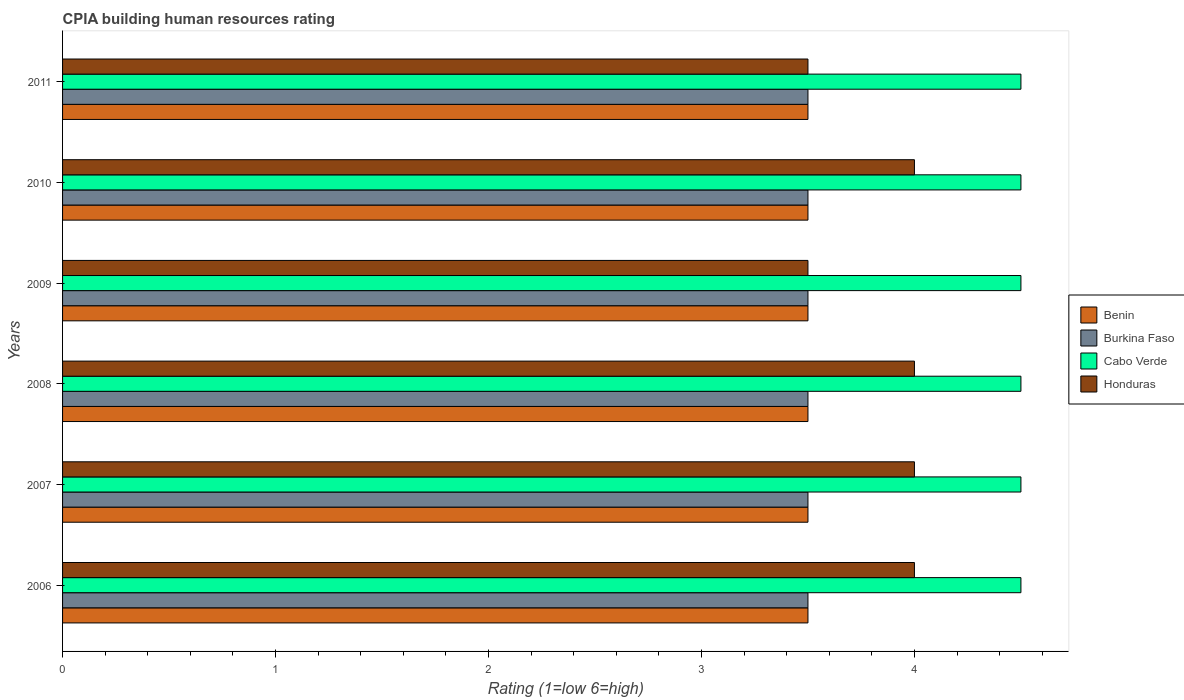How many different coloured bars are there?
Your answer should be very brief. 4. Are the number of bars per tick equal to the number of legend labels?
Provide a succinct answer. Yes. Are the number of bars on each tick of the Y-axis equal?
Provide a succinct answer. Yes. How many bars are there on the 3rd tick from the top?
Provide a succinct answer. 4. What is the label of the 1st group of bars from the top?
Offer a very short reply. 2011. In how many cases, is the number of bars for a given year not equal to the number of legend labels?
Your response must be concise. 0. Across all years, what is the maximum CPIA rating in Cabo Verde?
Ensure brevity in your answer.  4.5. Across all years, what is the minimum CPIA rating in Burkina Faso?
Your answer should be compact. 3.5. What is the difference between the CPIA rating in Benin in 2009 and that in 2010?
Your answer should be very brief. 0. In how many years, is the CPIA rating in Honduras greater than 3.2 ?
Your response must be concise. 6. Is the CPIA rating in Honduras in 2009 less than that in 2011?
Give a very brief answer. No. What is the difference between the highest and the second highest CPIA rating in Cabo Verde?
Give a very brief answer. 0. What is the difference between the highest and the lowest CPIA rating in Benin?
Keep it short and to the point. 0. In how many years, is the CPIA rating in Benin greater than the average CPIA rating in Benin taken over all years?
Provide a short and direct response. 0. Is it the case that in every year, the sum of the CPIA rating in Benin and CPIA rating in Cabo Verde is greater than the sum of CPIA rating in Honduras and CPIA rating in Burkina Faso?
Provide a succinct answer. Yes. What does the 2nd bar from the top in 2009 represents?
Provide a short and direct response. Cabo Verde. What does the 1st bar from the bottom in 2007 represents?
Your answer should be very brief. Benin. How many bars are there?
Give a very brief answer. 24. How many years are there in the graph?
Your response must be concise. 6. What is the difference between two consecutive major ticks on the X-axis?
Provide a short and direct response. 1. Are the values on the major ticks of X-axis written in scientific E-notation?
Offer a very short reply. No. Does the graph contain any zero values?
Offer a terse response. No. Does the graph contain grids?
Your answer should be very brief. No. Where does the legend appear in the graph?
Keep it short and to the point. Center right. How many legend labels are there?
Offer a terse response. 4. What is the title of the graph?
Give a very brief answer. CPIA building human resources rating. What is the label or title of the X-axis?
Keep it short and to the point. Rating (1=low 6=high). What is the Rating (1=low 6=high) of Benin in 2006?
Offer a terse response. 3.5. What is the Rating (1=low 6=high) of Honduras in 2006?
Ensure brevity in your answer.  4. What is the Rating (1=low 6=high) of Burkina Faso in 2007?
Provide a short and direct response. 3.5. What is the Rating (1=low 6=high) of Burkina Faso in 2008?
Make the answer very short. 3.5. What is the Rating (1=low 6=high) in Cabo Verde in 2008?
Make the answer very short. 4.5. What is the Rating (1=low 6=high) in Benin in 2009?
Your response must be concise. 3.5. What is the Rating (1=low 6=high) in Burkina Faso in 2009?
Your answer should be compact. 3.5. What is the Rating (1=low 6=high) in Honduras in 2010?
Offer a terse response. 4. What is the Rating (1=low 6=high) in Benin in 2011?
Offer a very short reply. 3.5. What is the Rating (1=low 6=high) in Cabo Verde in 2011?
Provide a succinct answer. 4.5. Across all years, what is the maximum Rating (1=low 6=high) of Honduras?
Give a very brief answer. 4. Across all years, what is the minimum Rating (1=low 6=high) in Burkina Faso?
Your response must be concise. 3.5. Across all years, what is the minimum Rating (1=low 6=high) of Cabo Verde?
Make the answer very short. 4.5. Across all years, what is the minimum Rating (1=low 6=high) in Honduras?
Your answer should be compact. 3.5. What is the total Rating (1=low 6=high) of Benin in the graph?
Ensure brevity in your answer.  21. What is the total Rating (1=low 6=high) of Cabo Verde in the graph?
Offer a terse response. 27. What is the total Rating (1=low 6=high) in Honduras in the graph?
Offer a very short reply. 23. What is the difference between the Rating (1=low 6=high) of Cabo Verde in 2006 and that in 2007?
Ensure brevity in your answer.  0. What is the difference between the Rating (1=low 6=high) of Benin in 2006 and that in 2008?
Provide a succinct answer. 0. What is the difference between the Rating (1=low 6=high) of Burkina Faso in 2006 and that in 2008?
Offer a very short reply. 0. What is the difference between the Rating (1=low 6=high) of Cabo Verde in 2006 and that in 2008?
Provide a short and direct response. 0. What is the difference between the Rating (1=low 6=high) of Benin in 2006 and that in 2009?
Your response must be concise. 0. What is the difference between the Rating (1=low 6=high) in Burkina Faso in 2006 and that in 2009?
Provide a succinct answer. 0. What is the difference between the Rating (1=low 6=high) of Cabo Verde in 2006 and that in 2009?
Offer a very short reply. 0. What is the difference between the Rating (1=low 6=high) in Honduras in 2006 and that in 2009?
Provide a succinct answer. 0.5. What is the difference between the Rating (1=low 6=high) in Benin in 2006 and that in 2010?
Keep it short and to the point. 0. What is the difference between the Rating (1=low 6=high) in Burkina Faso in 2006 and that in 2011?
Your response must be concise. 0. What is the difference between the Rating (1=low 6=high) of Cabo Verde in 2006 and that in 2011?
Ensure brevity in your answer.  0. What is the difference between the Rating (1=low 6=high) in Honduras in 2006 and that in 2011?
Make the answer very short. 0.5. What is the difference between the Rating (1=low 6=high) of Burkina Faso in 2007 and that in 2008?
Provide a short and direct response. 0. What is the difference between the Rating (1=low 6=high) in Honduras in 2007 and that in 2008?
Provide a short and direct response. 0. What is the difference between the Rating (1=low 6=high) of Cabo Verde in 2007 and that in 2009?
Your answer should be compact. 0. What is the difference between the Rating (1=low 6=high) of Honduras in 2007 and that in 2009?
Ensure brevity in your answer.  0.5. What is the difference between the Rating (1=low 6=high) in Burkina Faso in 2007 and that in 2010?
Make the answer very short. 0. What is the difference between the Rating (1=low 6=high) of Benin in 2007 and that in 2011?
Give a very brief answer. 0. What is the difference between the Rating (1=low 6=high) of Honduras in 2007 and that in 2011?
Your response must be concise. 0.5. What is the difference between the Rating (1=low 6=high) of Burkina Faso in 2008 and that in 2009?
Your response must be concise. 0. What is the difference between the Rating (1=low 6=high) in Cabo Verde in 2008 and that in 2010?
Offer a terse response. 0. What is the difference between the Rating (1=low 6=high) of Honduras in 2008 and that in 2010?
Offer a terse response. 0. What is the difference between the Rating (1=low 6=high) of Benin in 2008 and that in 2011?
Your answer should be very brief. 0. What is the difference between the Rating (1=low 6=high) of Burkina Faso in 2008 and that in 2011?
Keep it short and to the point. 0. What is the difference between the Rating (1=low 6=high) in Benin in 2009 and that in 2010?
Keep it short and to the point. 0. What is the difference between the Rating (1=low 6=high) of Cabo Verde in 2009 and that in 2010?
Keep it short and to the point. 0. What is the difference between the Rating (1=low 6=high) of Burkina Faso in 2009 and that in 2011?
Provide a succinct answer. 0. What is the difference between the Rating (1=low 6=high) of Cabo Verde in 2009 and that in 2011?
Make the answer very short. 0. What is the difference between the Rating (1=low 6=high) in Honduras in 2009 and that in 2011?
Offer a very short reply. 0. What is the difference between the Rating (1=low 6=high) in Benin in 2010 and that in 2011?
Provide a short and direct response. 0. What is the difference between the Rating (1=low 6=high) in Cabo Verde in 2010 and that in 2011?
Offer a terse response. 0. What is the difference between the Rating (1=low 6=high) in Burkina Faso in 2006 and the Rating (1=low 6=high) in Cabo Verde in 2007?
Offer a very short reply. -1. What is the difference between the Rating (1=low 6=high) of Cabo Verde in 2006 and the Rating (1=low 6=high) of Honduras in 2007?
Offer a very short reply. 0.5. What is the difference between the Rating (1=low 6=high) in Benin in 2006 and the Rating (1=low 6=high) in Burkina Faso in 2008?
Your answer should be compact. 0. What is the difference between the Rating (1=low 6=high) in Benin in 2006 and the Rating (1=low 6=high) in Cabo Verde in 2008?
Your answer should be compact. -1. What is the difference between the Rating (1=low 6=high) in Burkina Faso in 2006 and the Rating (1=low 6=high) in Honduras in 2008?
Your answer should be compact. -0.5. What is the difference between the Rating (1=low 6=high) of Benin in 2006 and the Rating (1=low 6=high) of Burkina Faso in 2009?
Your response must be concise. 0. What is the difference between the Rating (1=low 6=high) in Benin in 2006 and the Rating (1=low 6=high) in Honduras in 2009?
Provide a succinct answer. 0. What is the difference between the Rating (1=low 6=high) of Burkina Faso in 2006 and the Rating (1=low 6=high) of Honduras in 2009?
Make the answer very short. 0. What is the difference between the Rating (1=low 6=high) in Cabo Verde in 2006 and the Rating (1=low 6=high) in Honduras in 2009?
Provide a short and direct response. 1. What is the difference between the Rating (1=low 6=high) of Burkina Faso in 2006 and the Rating (1=low 6=high) of Honduras in 2010?
Your answer should be compact. -0.5. What is the difference between the Rating (1=low 6=high) in Benin in 2006 and the Rating (1=low 6=high) in Cabo Verde in 2011?
Keep it short and to the point. -1. What is the difference between the Rating (1=low 6=high) of Benin in 2007 and the Rating (1=low 6=high) of Burkina Faso in 2008?
Ensure brevity in your answer.  0. What is the difference between the Rating (1=low 6=high) in Benin in 2007 and the Rating (1=low 6=high) in Cabo Verde in 2008?
Offer a terse response. -1. What is the difference between the Rating (1=low 6=high) of Benin in 2007 and the Rating (1=low 6=high) of Honduras in 2008?
Ensure brevity in your answer.  -0.5. What is the difference between the Rating (1=low 6=high) in Burkina Faso in 2007 and the Rating (1=low 6=high) in Cabo Verde in 2008?
Provide a succinct answer. -1. What is the difference between the Rating (1=low 6=high) of Benin in 2007 and the Rating (1=low 6=high) of Burkina Faso in 2009?
Give a very brief answer. 0. What is the difference between the Rating (1=low 6=high) of Benin in 2007 and the Rating (1=low 6=high) of Cabo Verde in 2009?
Make the answer very short. -1. What is the difference between the Rating (1=low 6=high) in Benin in 2007 and the Rating (1=low 6=high) in Honduras in 2009?
Provide a succinct answer. 0. What is the difference between the Rating (1=low 6=high) in Burkina Faso in 2007 and the Rating (1=low 6=high) in Honduras in 2009?
Keep it short and to the point. 0. What is the difference between the Rating (1=low 6=high) in Cabo Verde in 2007 and the Rating (1=low 6=high) in Honduras in 2009?
Give a very brief answer. 1. What is the difference between the Rating (1=low 6=high) in Burkina Faso in 2007 and the Rating (1=low 6=high) in Honduras in 2010?
Make the answer very short. -0.5. What is the difference between the Rating (1=low 6=high) in Cabo Verde in 2007 and the Rating (1=low 6=high) in Honduras in 2010?
Ensure brevity in your answer.  0.5. What is the difference between the Rating (1=low 6=high) in Benin in 2007 and the Rating (1=low 6=high) in Burkina Faso in 2011?
Offer a very short reply. 0. What is the difference between the Rating (1=low 6=high) of Benin in 2007 and the Rating (1=low 6=high) of Cabo Verde in 2011?
Your response must be concise. -1. What is the difference between the Rating (1=low 6=high) of Benin in 2007 and the Rating (1=low 6=high) of Honduras in 2011?
Offer a very short reply. 0. What is the difference between the Rating (1=low 6=high) of Benin in 2008 and the Rating (1=low 6=high) of Burkina Faso in 2009?
Ensure brevity in your answer.  0. What is the difference between the Rating (1=low 6=high) of Cabo Verde in 2008 and the Rating (1=low 6=high) of Honduras in 2009?
Offer a terse response. 1. What is the difference between the Rating (1=low 6=high) in Benin in 2008 and the Rating (1=low 6=high) in Cabo Verde in 2010?
Provide a short and direct response. -1. What is the difference between the Rating (1=low 6=high) in Benin in 2008 and the Rating (1=low 6=high) in Honduras in 2010?
Your response must be concise. -0.5. What is the difference between the Rating (1=low 6=high) of Burkina Faso in 2008 and the Rating (1=low 6=high) of Cabo Verde in 2010?
Provide a short and direct response. -1. What is the difference between the Rating (1=low 6=high) in Cabo Verde in 2008 and the Rating (1=low 6=high) in Honduras in 2010?
Give a very brief answer. 0.5. What is the difference between the Rating (1=low 6=high) in Benin in 2008 and the Rating (1=low 6=high) in Burkina Faso in 2011?
Your response must be concise. 0. What is the difference between the Rating (1=low 6=high) of Benin in 2008 and the Rating (1=low 6=high) of Honduras in 2011?
Make the answer very short. 0. What is the difference between the Rating (1=low 6=high) of Burkina Faso in 2008 and the Rating (1=low 6=high) of Cabo Verde in 2011?
Give a very brief answer. -1. What is the difference between the Rating (1=low 6=high) in Cabo Verde in 2008 and the Rating (1=low 6=high) in Honduras in 2011?
Your response must be concise. 1. What is the difference between the Rating (1=low 6=high) of Benin in 2009 and the Rating (1=low 6=high) of Burkina Faso in 2010?
Your response must be concise. 0. What is the difference between the Rating (1=low 6=high) of Cabo Verde in 2009 and the Rating (1=low 6=high) of Honduras in 2010?
Provide a short and direct response. 0.5. What is the difference between the Rating (1=low 6=high) in Benin in 2009 and the Rating (1=low 6=high) in Burkina Faso in 2011?
Your answer should be very brief. 0. What is the difference between the Rating (1=low 6=high) of Benin in 2009 and the Rating (1=low 6=high) of Cabo Verde in 2011?
Provide a short and direct response. -1. What is the difference between the Rating (1=low 6=high) of Benin in 2009 and the Rating (1=low 6=high) of Honduras in 2011?
Your answer should be compact. 0. What is the difference between the Rating (1=low 6=high) of Burkina Faso in 2009 and the Rating (1=low 6=high) of Honduras in 2011?
Your response must be concise. 0. What is the difference between the Rating (1=low 6=high) of Benin in 2010 and the Rating (1=low 6=high) of Burkina Faso in 2011?
Offer a terse response. 0. What is the difference between the Rating (1=low 6=high) of Cabo Verde in 2010 and the Rating (1=low 6=high) of Honduras in 2011?
Your answer should be very brief. 1. What is the average Rating (1=low 6=high) in Burkina Faso per year?
Offer a very short reply. 3.5. What is the average Rating (1=low 6=high) in Cabo Verde per year?
Offer a very short reply. 4.5. What is the average Rating (1=low 6=high) of Honduras per year?
Ensure brevity in your answer.  3.83. In the year 2006, what is the difference between the Rating (1=low 6=high) in Benin and Rating (1=low 6=high) in Honduras?
Your answer should be very brief. -0.5. In the year 2006, what is the difference between the Rating (1=low 6=high) in Burkina Faso and Rating (1=low 6=high) in Cabo Verde?
Give a very brief answer. -1. In the year 2006, what is the difference between the Rating (1=low 6=high) of Cabo Verde and Rating (1=low 6=high) of Honduras?
Offer a terse response. 0.5. In the year 2007, what is the difference between the Rating (1=low 6=high) in Benin and Rating (1=low 6=high) in Burkina Faso?
Provide a short and direct response. 0. In the year 2007, what is the difference between the Rating (1=low 6=high) of Benin and Rating (1=low 6=high) of Honduras?
Ensure brevity in your answer.  -0.5. In the year 2007, what is the difference between the Rating (1=low 6=high) of Burkina Faso and Rating (1=low 6=high) of Cabo Verde?
Ensure brevity in your answer.  -1. In the year 2008, what is the difference between the Rating (1=low 6=high) of Benin and Rating (1=low 6=high) of Burkina Faso?
Your answer should be very brief. 0. In the year 2008, what is the difference between the Rating (1=low 6=high) in Benin and Rating (1=low 6=high) in Honduras?
Your response must be concise. -0.5. In the year 2008, what is the difference between the Rating (1=low 6=high) of Burkina Faso and Rating (1=low 6=high) of Cabo Verde?
Provide a succinct answer. -1. In the year 2008, what is the difference between the Rating (1=low 6=high) in Burkina Faso and Rating (1=low 6=high) in Honduras?
Give a very brief answer. -0.5. In the year 2009, what is the difference between the Rating (1=low 6=high) of Benin and Rating (1=low 6=high) of Burkina Faso?
Make the answer very short. 0. In the year 2009, what is the difference between the Rating (1=low 6=high) in Benin and Rating (1=low 6=high) in Cabo Verde?
Offer a terse response. -1. In the year 2009, what is the difference between the Rating (1=low 6=high) in Burkina Faso and Rating (1=low 6=high) in Cabo Verde?
Your response must be concise. -1. In the year 2010, what is the difference between the Rating (1=low 6=high) in Benin and Rating (1=low 6=high) in Burkina Faso?
Make the answer very short. 0. In the year 2010, what is the difference between the Rating (1=low 6=high) of Benin and Rating (1=low 6=high) of Cabo Verde?
Provide a short and direct response. -1. In the year 2010, what is the difference between the Rating (1=low 6=high) in Benin and Rating (1=low 6=high) in Honduras?
Make the answer very short. -0.5. In the year 2010, what is the difference between the Rating (1=low 6=high) of Burkina Faso and Rating (1=low 6=high) of Honduras?
Your response must be concise. -0.5. In the year 2011, what is the difference between the Rating (1=low 6=high) of Cabo Verde and Rating (1=low 6=high) of Honduras?
Provide a short and direct response. 1. What is the ratio of the Rating (1=low 6=high) in Benin in 2006 to that in 2007?
Give a very brief answer. 1. What is the ratio of the Rating (1=low 6=high) of Cabo Verde in 2006 to that in 2007?
Provide a short and direct response. 1. What is the ratio of the Rating (1=low 6=high) in Benin in 2006 to that in 2008?
Your answer should be very brief. 1. What is the ratio of the Rating (1=low 6=high) in Burkina Faso in 2006 to that in 2009?
Make the answer very short. 1. What is the ratio of the Rating (1=low 6=high) in Cabo Verde in 2006 to that in 2009?
Give a very brief answer. 1. What is the ratio of the Rating (1=low 6=high) in Cabo Verde in 2006 to that in 2010?
Make the answer very short. 1. What is the ratio of the Rating (1=low 6=high) of Honduras in 2006 to that in 2010?
Offer a very short reply. 1. What is the ratio of the Rating (1=low 6=high) in Benin in 2006 to that in 2011?
Ensure brevity in your answer.  1. What is the ratio of the Rating (1=low 6=high) in Cabo Verde in 2006 to that in 2011?
Give a very brief answer. 1. What is the ratio of the Rating (1=low 6=high) in Burkina Faso in 2007 to that in 2008?
Keep it short and to the point. 1. What is the ratio of the Rating (1=low 6=high) in Burkina Faso in 2007 to that in 2009?
Provide a short and direct response. 1. What is the ratio of the Rating (1=low 6=high) of Cabo Verde in 2007 to that in 2009?
Your answer should be compact. 1. What is the ratio of the Rating (1=low 6=high) in Cabo Verde in 2007 to that in 2011?
Offer a very short reply. 1. What is the ratio of the Rating (1=low 6=high) of Benin in 2008 to that in 2009?
Provide a succinct answer. 1. What is the ratio of the Rating (1=low 6=high) in Cabo Verde in 2008 to that in 2009?
Your answer should be very brief. 1. What is the ratio of the Rating (1=low 6=high) of Burkina Faso in 2008 to that in 2010?
Provide a succinct answer. 1. What is the ratio of the Rating (1=low 6=high) of Cabo Verde in 2008 to that in 2010?
Your answer should be very brief. 1. What is the ratio of the Rating (1=low 6=high) in Honduras in 2008 to that in 2010?
Keep it short and to the point. 1. What is the ratio of the Rating (1=low 6=high) of Burkina Faso in 2008 to that in 2011?
Your answer should be compact. 1. What is the ratio of the Rating (1=low 6=high) of Cabo Verde in 2008 to that in 2011?
Your answer should be very brief. 1. What is the ratio of the Rating (1=low 6=high) in Honduras in 2008 to that in 2011?
Your answer should be compact. 1.14. What is the ratio of the Rating (1=low 6=high) in Benin in 2009 to that in 2010?
Ensure brevity in your answer.  1. What is the ratio of the Rating (1=low 6=high) in Burkina Faso in 2009 to that in 2010?
Offer a terse response. 1. What is the ratio of the Rating (1=low 6=high) of Cabo Verde in 2009 to that in 2011?
Provide a succinct answer. 1. What is the ratio of the Rating (1=low 6=high) of Benin in 2010 to that in 2011?
Keep it short and to the point. 1. What is the ratio of the Rating (1=low 6=high) of Burkina Faso in 2010 to that in 2011?
Your answer should be compact. 1. What is the ratio of the Rating (1=low 6=high) of Cabo Verde in 2010 to that in 2011?
Provide a succinct answer. 1. What is the difference between the highest and the second highest Rating (1=low 6=high) of Benin?
Your answer should be very brief. 0. What is the difference between the highest and the second highest Rating (1=low 6=high) in Honduras?
Provide a short and direct response. 0. What is the difference between the highest and the lowest Rating (1=low 6=high) in Cabo Verde?
Offer a very short reply. 0. What is the difference between the highest and the lowest Rating (1=low 6=high) in Honduras?
Offer a terse response. 0.5. 